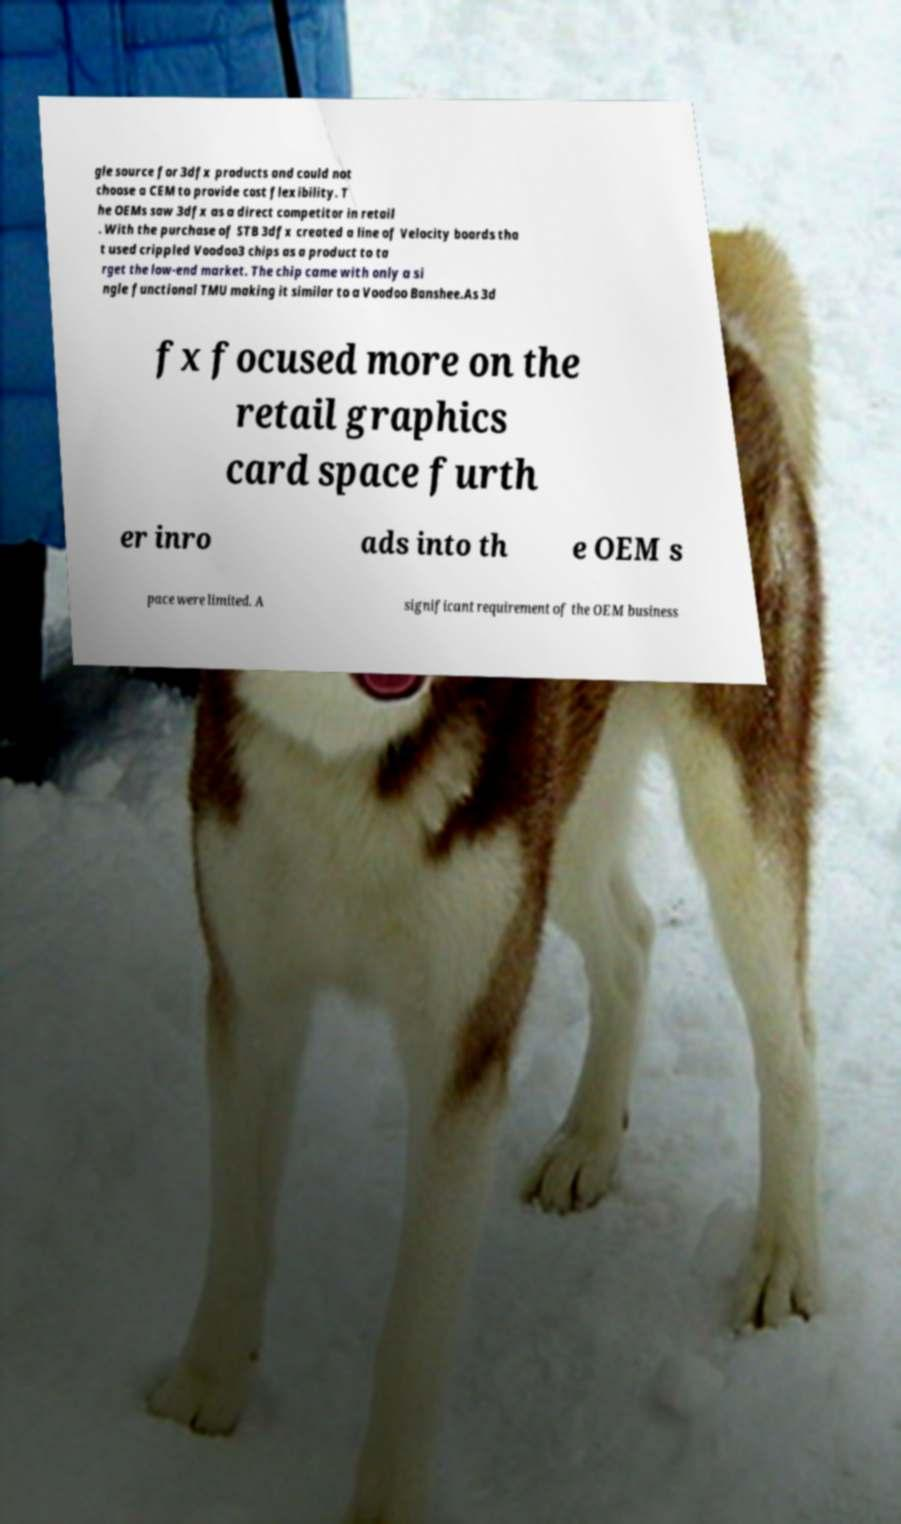Please identify and transcribe the text found in this image. gle source for 3dfx products and could not choose a CEM to provide cost flexibility. T he OEMs saw 3dfx as a direct competitor in retail . With the purchase of STB 3dfx created a line of Velocity boards tha t used crippled Voodoo3 chips as a product to ta rget the low-end market. The chip came with only a si ngle functional TMU making it similar to a Voodoo Banshee.As 3d fx focused more on the retail graphics card space furth er inro ads into th e OEM s pace were limited. A significant requirement of the OEM business 